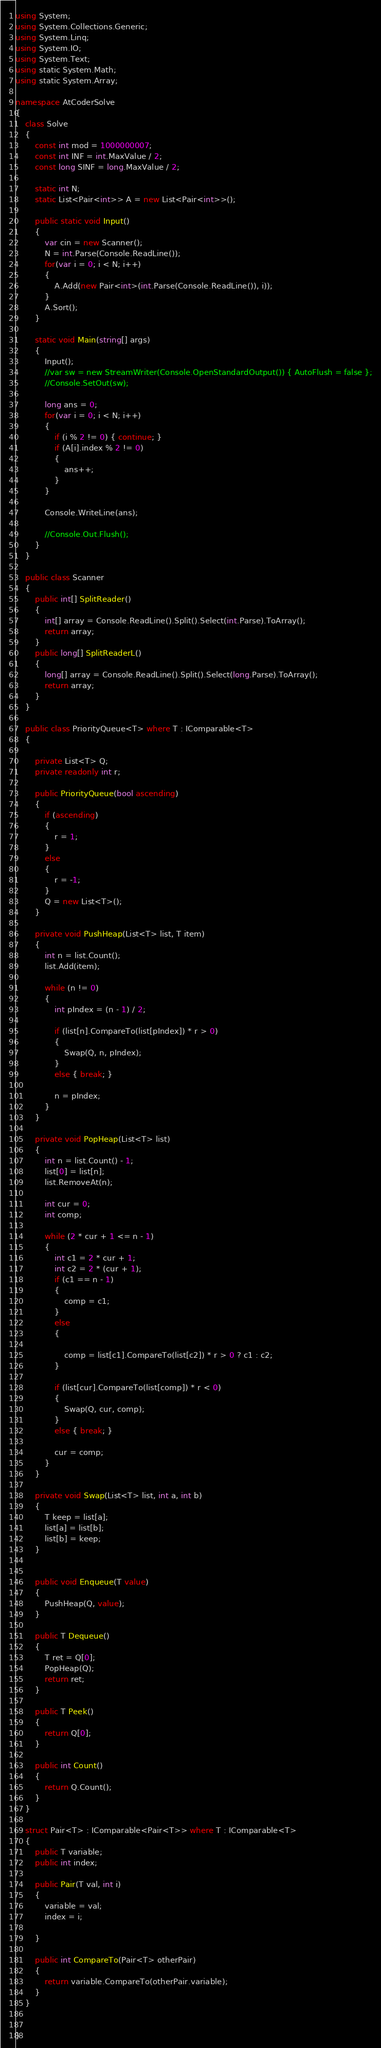<code> <loc_0><loc_0><loc_500><loc_500><_C#_>using System;
using System.Collections.Generic;
using System.Linq;
using System.IO;
using System.Text;
using static System.Math;
using static System.Array;

namespace AtCoderSolve
{
    class Solve
    {
        const int mod = 1000000007;
        const int INF = int.MaxValue / 2;
        const long SINF = long.MaxValue / 2;

        static int N;
        static List<Pair<int>> A = new List<Pair<int>>();

        public static void Input()
        {
            var cin = new Scanner();
            N = int.Parse(Console.ReadLine());
            for(var i = 0; i < N; i++)
            {
                A.Add(new Pair<int>(int.Parse(Console.ReadLine()), i));
            }
            A.Sort();
        }

        static void Main(string[] args)
        {
            Input();
            //var sw = new StreamWriter(Console.OpenStandardOutput()) { AutoFlush = false };
            //Console.SetOut(sw);

            long ans = 0;
            for(var i = 0; i < N; i++)
            {
                if (i % 2 != 0) { continue; }
                if (A[i].index % 2 != 0)
                {
                    ans++;
                }
            }

            Console.WriteLine(ans);           

            //Console.Out.Flush();
        }
    }

    public class Scanner
    {
        public int[] SplitReader()
        {
            int[] array = Console.ReadLine().Split().Select(int.Parse).ToArray();
            return array;
        }
        public long[] SplitReaderL()
        {
            long[] array = Console.ReadLine().Split().Select(long.Parse).ToArray();
            return array;
        }
    }

    public class PriorityQueue<T> where T : IComparable<T>
    {
       
        private List<T> Q;
        private readonly int r;

        public PriorityQueue(bool ascending)
        {
            if (ascending)
            {
                r = 1;
            }
            else
            {
                r = -1;
            }
            Q = new List<T>();
        }

        private void PushHeap(List<T> list, T item)
        {
            int n = list.Count();
            list.Add(item);

            while (n != 0)
            {
                int pIndex = (n - 1) / 2;

                if (list[n].CompareTo(list[pIndex]) * r > 0)
                {
                    Swap(Q, n, pIndex);
                }
                else { break; }

                n = pIndex;
            }
        }

        private void PopHeap(List<T> list)
        {
            int n = list.Count() - 1;
            list[0] = list[n];
            list.RemoveAt(n);

            int cur = 0;
            int comp;

            while (2 * cur + 1 <= n - 1)
            {
                int c1 = 2 * cur + 1;
                int c2 = 2 * (cur + 1);
                if (c1 == n - 1)
                {
                    comp = c1;
                }
                else
                {

                    comp = list[c1].CompareTo(list[c2]) * r > 0 ? c1 : c2;
                }

                if (list[cur].CompareTo(list[comp]) * r < 0)
                {
                    Swap(Q, cur, comp);
                }
                else { break; }

                cur = comp;
            }
        }

        private void Swap(List<T> list, int a, int b)
        {
            T keep = list[a];
            list[a] = list[b];
            list[b] = keep;
        }


        public void Enqueue(T value)
        {
            PushHeap(Q, value);
        }

        public T Dequeue()
        {
            T ret = Q[0];
            PopHeap(Q);
            return ret;
        }

        public T Peek()
        {
            return Q[0];
        }

        public int Count()
        {
            return Q.Count();
        }
    }

    struct Pair<T> : IComparable<Pair<T>> where T : IComparable<T>
    {
        public T variable;
        public int index;

        public Pair(T val, int i)
        {
            variable = val;
            index = i;
            
        }

        public int CompareTo(Pair<T> otherPair)
        {
            return variable.CompareTo(otherPair.variable);
        }
    }


}




</code> 